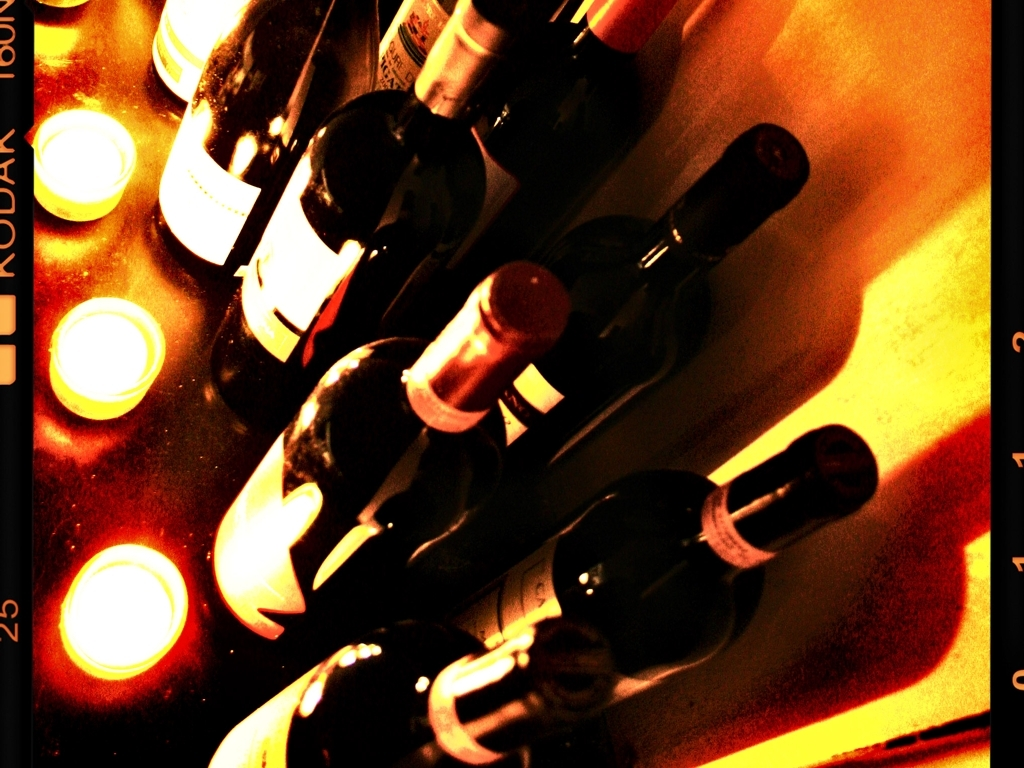Is the picture properly exposed? The assessment of whether the image is properly exposed is subjective to some extent. However, in this case, the image appears to be purposefully overexposed in certain areas, creating a high-contrast look that can be seen as a stylistic choice. It deviates from a neutral exposure, where all elements are evenly lit without overly bright or dark areas. As a result, while it's not 'properly' exposed in the classic sense, the effect may be intentional to evoke a particular mood or aesthetic. 